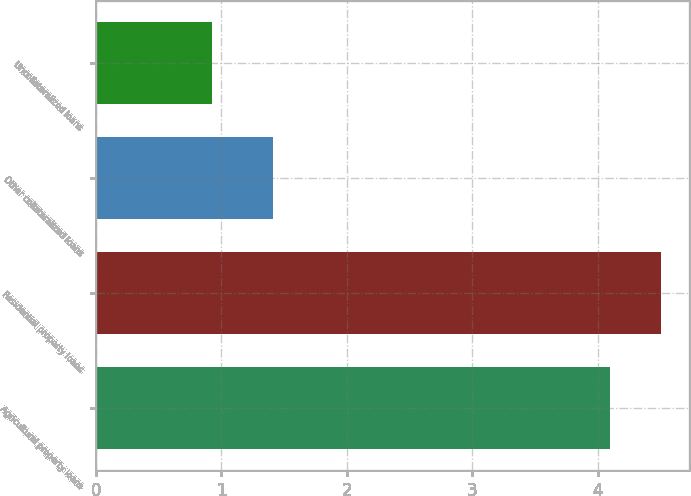<chart> <loc_0><loc_0><loc_500><loc_500><bar_chart><fcel>Agricultural property loans<fcel>Residential property loans<fcel>Other collateralized loans<fcel>Uncollateralized loans<nl><fcel>4.1<fcel>4.5<fcel>1.41<fcel>0.93<nl></chart> 